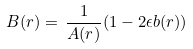Convert formula to latex. <formula><loc_0><loc_0><loc_500><loc_500>B ( r ) = \, \frac { 1 } { A ( r ) } ( 1 - 2 \epsilon b ( r ) ) \,</formula> 